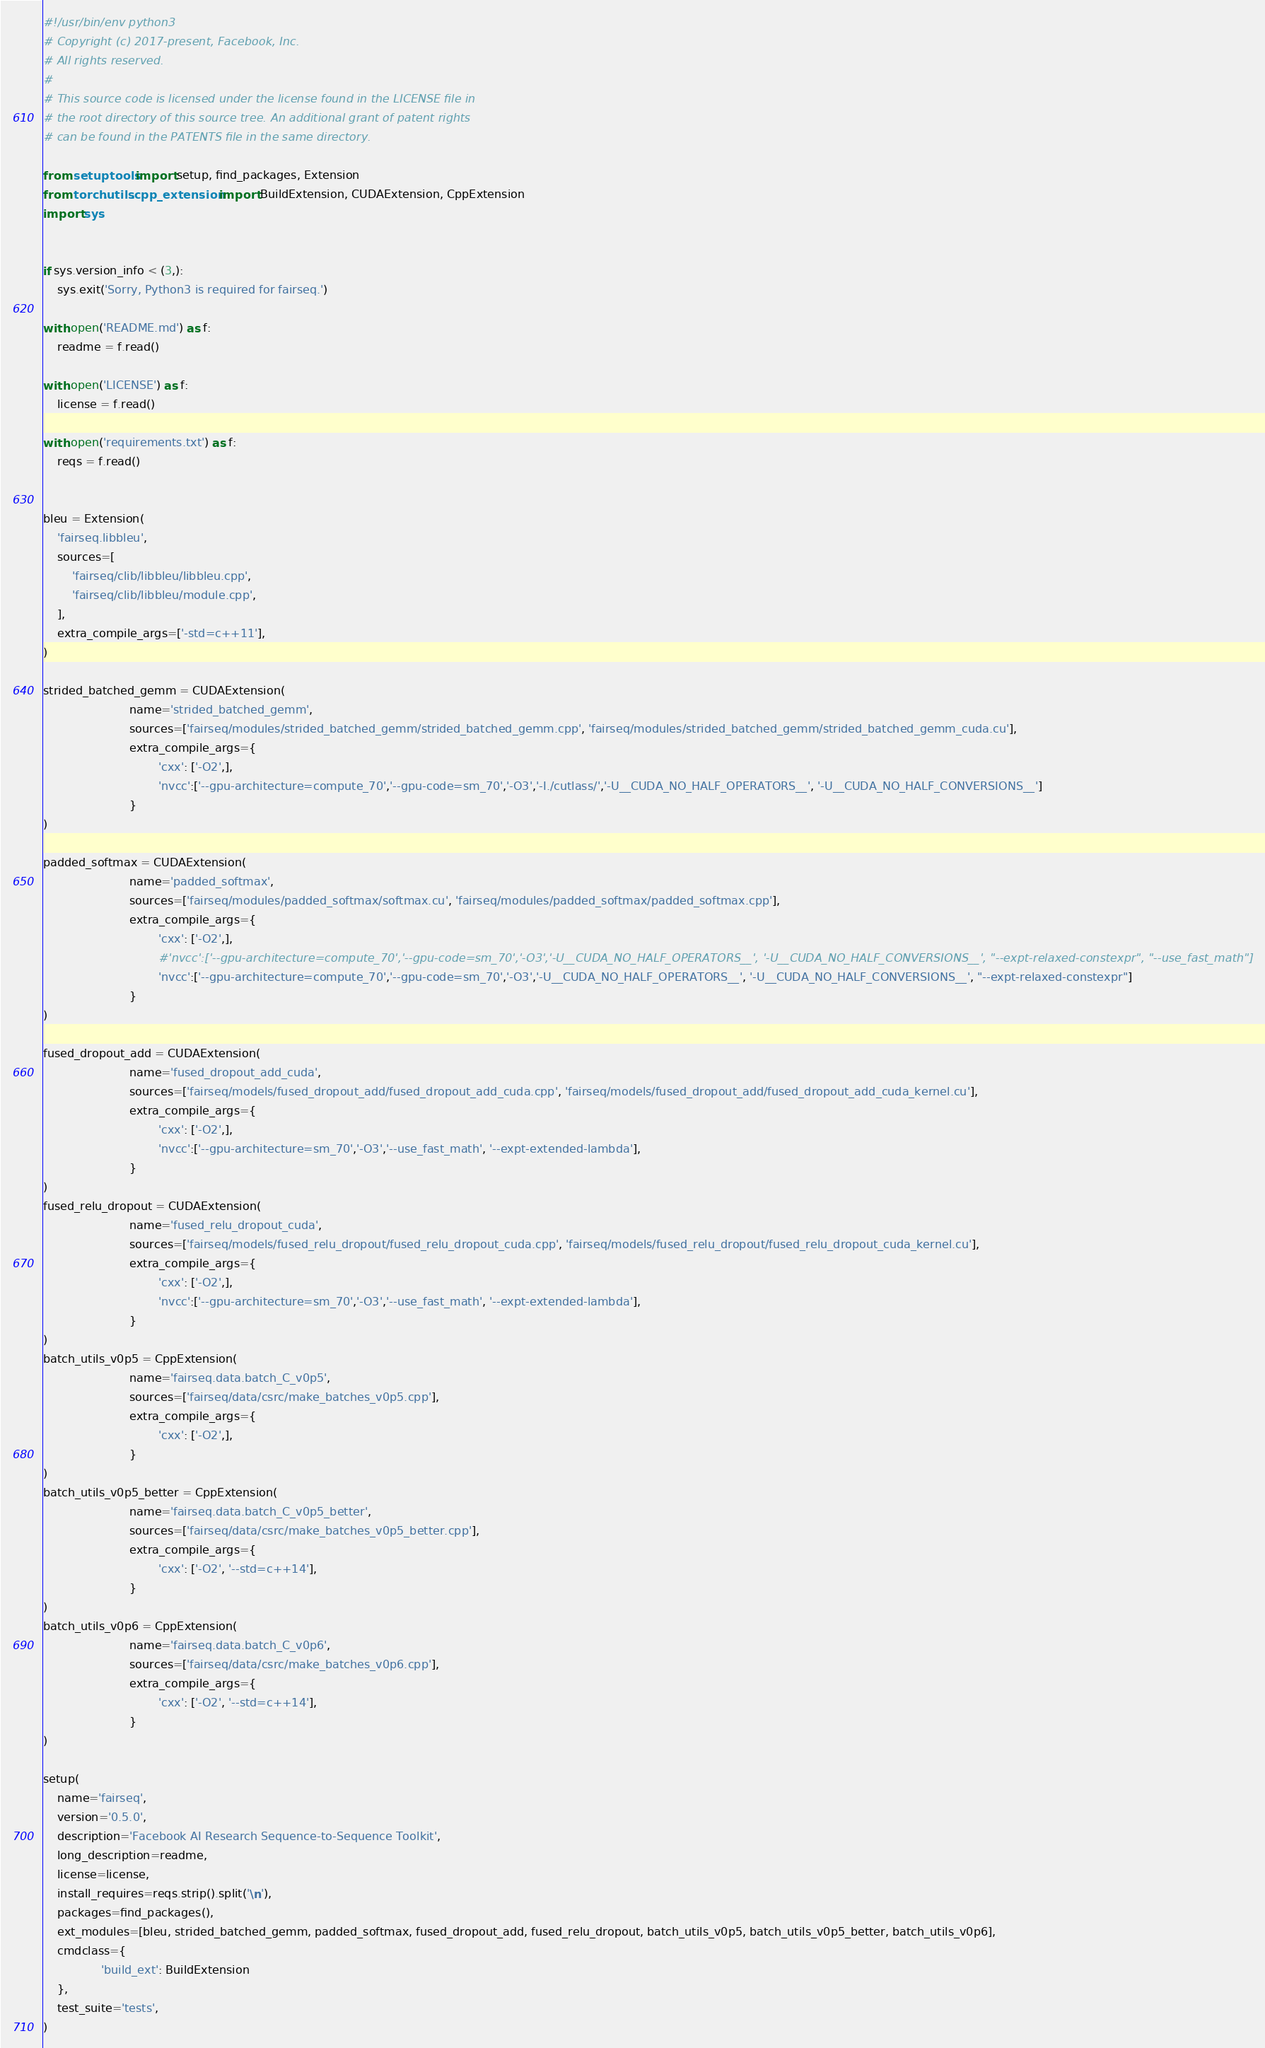Convert code to text. <code><loc_0><loc_0><loc_500><loc_500><_Python_>#!/usr/bin/env python3
# Copyright (c) 2017-present, Facebook, Inc.
# All rights reserved.
#
# This source code is licensed under the license found in the LICENSE file in
# the root directory of this source tree. An additional grant of patent rights
# can be found in the PATENTS file in the same directory.

from setuptools import setup, find_packages, Extension
from torch.utils.cpp_extension import BuildExtension, CUDAExtension, CppExtension
import sys


if sys.version_info < (3,):
    sys.exit('Sorry, Python3 is required for fairseq.')

with open('README.md') as f:
    readme = f.read()

with open('LICENSE') as f:
    license = f.read()

with open('requirements.txt') as f:
    reqs = f.read()


bleu = Extension(
    'fairseq.libbleu',
    sources=[
        'fairseq/clib/libbleu/libbleu.cpp',
        'fairseq/clib/libbleu/module.cpp',
    ],
    extra_compile_args=['-std=c++11'],
)

strided_batched_gemm = CUDAExtension(
                        name='strided_batched_gemm',
                        sources=['fairseq/modules/strided_batched_gemm/strided_batched_gemm.cpp', 'fairseq/modules/strided_batched_gemm/strided_batched_gemm_cuda.cu'],
                        extra_compile_args={
                                'cxx': ['-O2',],
                                'nvcc':['--gpu-architecture=compute_70','--gpu-code=sm_70','-O3','-I./cutlass/','-U__CUDA_NO_HALF_OPERATORS__', '-U__CUDA_NO_HALF_CONVERSIONS__']
                        }
)

padded_softmax = CUDAExtension(
                        name='padded_softmax',
                        sources=['fairseq/modules/padded_softmax/softmax.cu', 'fairseq/modules/padded_softmax/padded_softmax.cpp'],
                        extra_compile_args={
                                'cxx': ['-O2',],
                                #'nvcc':['--gpu-architecture=compute_70','--gpu-code=sm_70','-O3','-U__CUDA_NO_HALF_OPERATORS__', '-U__CUDA_NO_HALF_CONVERSIONS__', "--expt-relaxed-constexpr", "--use_fast_math"]
                                'nvcc':['--gpu-architecture=compute_70','--gpu-code=sm_70','-O3','-U__CUDA_NO_HALF_OPERATORS__', '-U__CUDA_NO_HALF_CONVERSIONS__', "--expt-relaxed-constexpr"]
                        }
)

fused_dropout_add = CUDAExtension(
                        name='fused_dropout_add_cuda',
                        sources=['fairseq/models/fused_dropout_add/fused_dropout_add_cuda.cpp', 'fairseq/models/fused_dropout_add/fused_dropout_add_cuda_kernel.cu'],
                        extra_compile_args={
                                'cxx': ['-O2',],
                                'nvcc':['--gpu-architecture=sm_70','-O3','--use_fast_math', '--expt-extended-lambda'],
                        }
)
fused_relu_dropout = CUDAExtension(
                        name='fused_relu_dropout_cuda',
                        sources=['fairseq/models/fused_relu_dropout/fused_relu_dropout_cuda.cpp', 'fairseq/models/fused_relu_dropout/fused_relu_dropout_cuda_kernel.cu'],
                        extra_compile_args={
                                'cxx': ['-O2',],
                                'nvcc':['--gpu-architecture=sm_70','-O3','--use_fast_math', '--expt-extended-lambda'],
                        }
)
batch_utils_v0p5 = CppExtension(
                        name='fairseq.data.batch_C_v0p5',
                        sources=['fairseq/data/csrc/make_batches_v0p5.cpp'],
                        extra_compile_args={
                                'cxx': ['-O2',],
                        }
)
batch_utils_v0p5_better = CppExtension(
                        name='fairseq.data.batch_C_v0p5_better',
                        sources=['fairseq/data/csrc/make_batches_v0p5_better.cpp'],
                        extra_compile_args={
                                'cxx': ['-O2', '--std=c++14'],
                        }
)
batch_utils_v0p6 = CppExtension(
                        name='fairseq.data.batch_C_v0p6',
                        sources=['fairseq/data/csrc/make_batches_v0p6.cpp'],
                        extra_compile_args={
                                'cxx': ['-O2', '--std=c++14'],
                        }
)

setup(
    name='fairseq',
    version='0.5.0',
    description='Facebook AI Research Sequence-to-Sequence Toolkit',
    long_description=readme,
    license=license,
    install_requires=reqs.strip().split('\n'),
    packages=find_packages(),
    ext_modules=[bleu, strided_batched_gemm, padded_softmax, fused_dropout_add, fused_relu_dropout, batch_utils_v0p5, batch_utils_v0p5_better, batch_utils_v0p6],
    cmdclass={
                'build_ext': BuildExtension
    },
    test_suite='tests',
)
</code> 